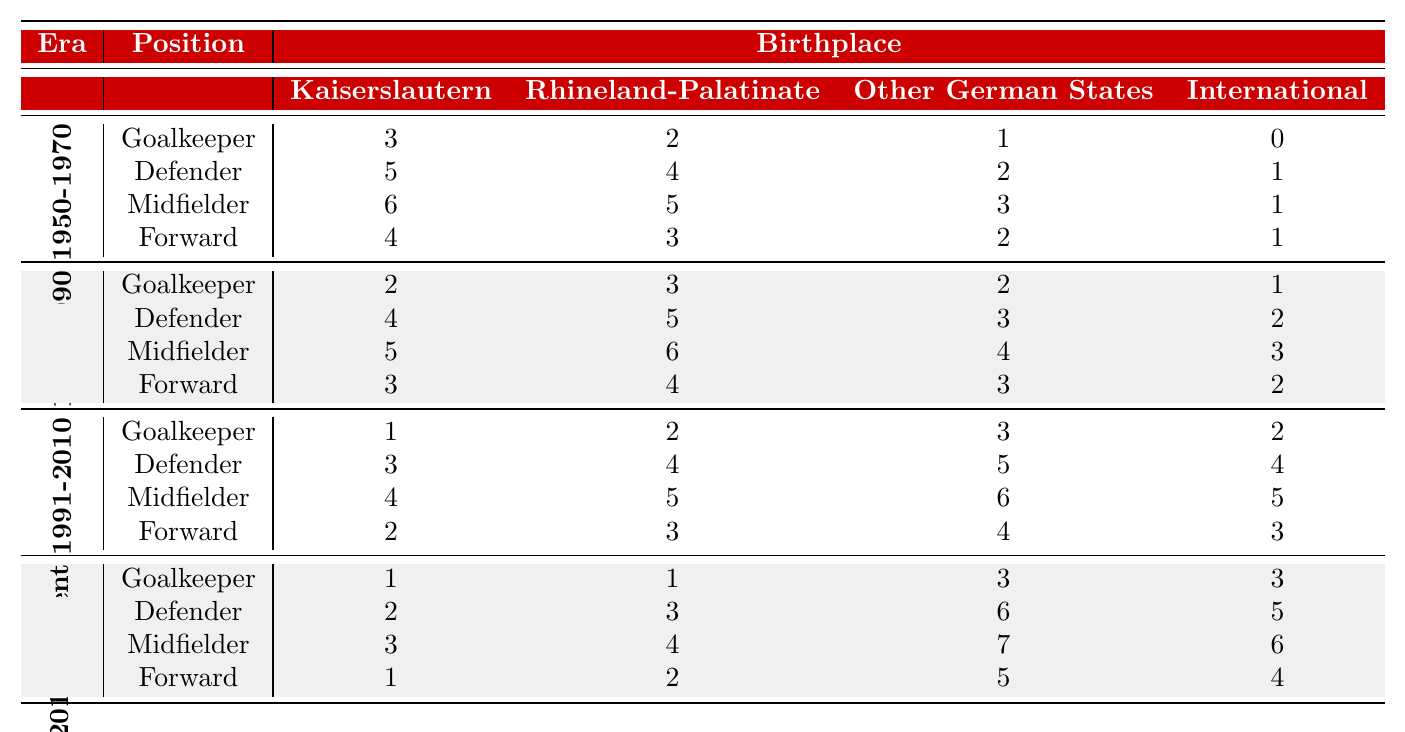What was the highest number of midfielders from Kaiserslautern in the 1950-1970 era? In the 1950-1970 era, there were 6 midfielders from Kaiserslautern, which is the highest number for that position in that era.
Answer: 6 How many forwards were from Rhineland-Palatinate during the 1991-2010 era? In the 1991-2010 era, there were 3 forwards from Rhineland-Palatinate.
Answer: 3 Did any goalkeepers from Kaiserslautern play in the 2011-present era? Yes, there was 1 goalkeeper from Kaiserslautern in the 2011-present era.
Answer: Yes Which position saw the lowest number of international players in the 1971-1990 era? In the 1971-1990 era, the position with the lowest number of international players was goalkeeper, with only 1 international player.
Answer: Goalkeeper What is the total number of defenders from Kaiserslautern across all eras? The total number of defenders from Kaiserslautern is calculated as 5 (1950-1970) + 4 (1971-1990) + 3 (1991-2010) + 2 (2011-present) = 14 defenders.
Answer: 14 Which era had the highest number of midfielders from Other German States? The 2011-present era had the highest number of midfielders from Other German States, with 7 players.
Answer: 2011-present Are there more forwards from Kaiserslautern in the 1991-2010 era compared to the 2011-present era? Yes, there were 2 forwards from Kaiserslautern in the 1991-2010 era and only 1 in the 2011-present era.
Answer: Yes What is the average number of defenders from Rhineland-Palatinate across all eras? The average is calculated as follows: (4 + 5 + 4 + 3) / 4 = 4. Since there are 4 eras, the average number of defenders from Rhineland-Palatinate is 4.
Answer: 4 Which era had a higher count of international midfielders, 1991-2010 or 2011-present? The 1991-2010 era had 5 international midfielders, while the 2011-present era had 6, meaning 2011-present had a higher count.
Answer: 2011-present What is the total number of players from ‘Other German States’ in the Forward position during the 1971-1990 era? In the 1971-1990 era, there were 3 forwards from Other German States, which is the total for that era in that position.
Answer: 3 